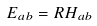<formula> <loc_0><loc_0><loc_500><loc_500>E _ { a b } = R H _ { a b }</formula> 